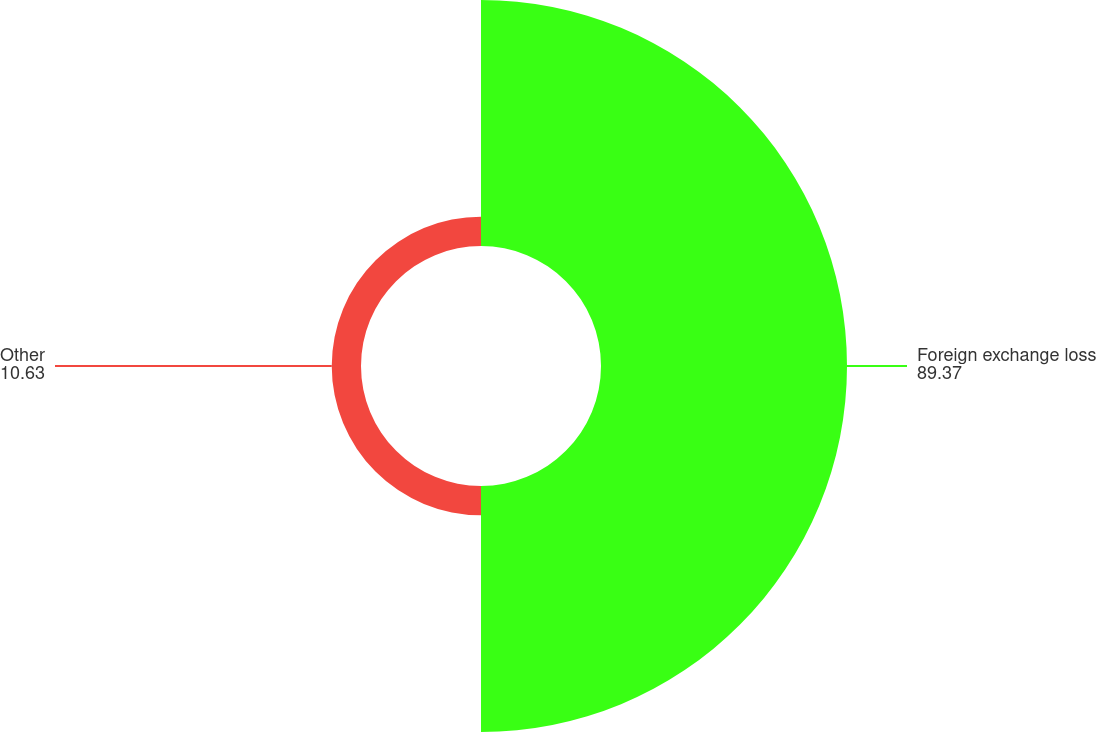Convert chart. <chart><loc_0><loc_0><loc_500><loc_500><pie_chart><fcel>Foreign exchange loss<fcel>Other<nl><fcel>89.37%<fcel>10.63%<nl></chart> 